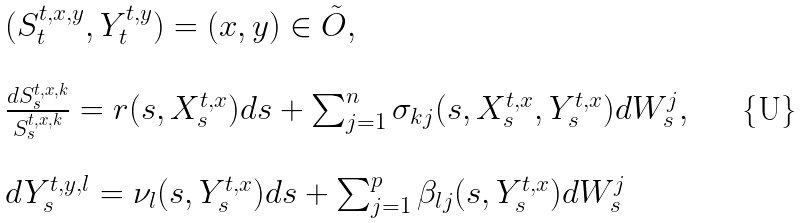<formula> <loc_0><loc_0><loc_500><loc_500>\begin{array} { l l } ( S _ { t } ^ { t , x , y } , Y _ { t } ^ { t , y } ) = ( x , y ) \in \tilde { O } , \\ \\ \frac { d S _ { s } ^ { t , x , k } } { S _ { s } ^ { t , x , k } } = r ( s , X _ { s } ^ { t , x } ) d s + \sum _ { j = 1 } ^ { n } \sigma _ { k j } ( s , X _ { s } ^ { t , x } , Y _ { s } ^ { t , x } ) d W ^ { j } _ { s } , \\ \\ d Y _ { s } ^ { t , y , l } = \nu _ { l } ( s , Y _ { s } ^ { t , x } ) d s + \sum _ { j = 1 } ^ { p } \beta _ { l j } ( s , Y _ { s } ^ { t , x } ) d W ^ { j } _ { s } \end{array}</formula> 